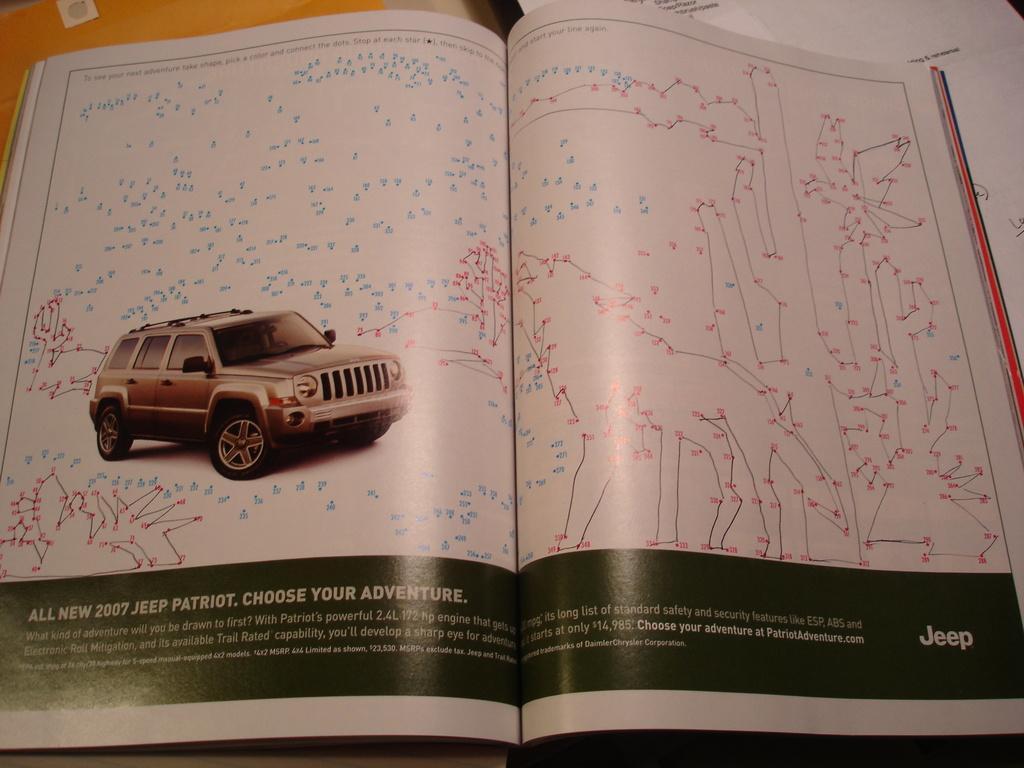Can you describe this image briefly? In the image we can see a book, in the book we can see a vehicle and these are the headlights of the vehicle, and this is a printed text. 